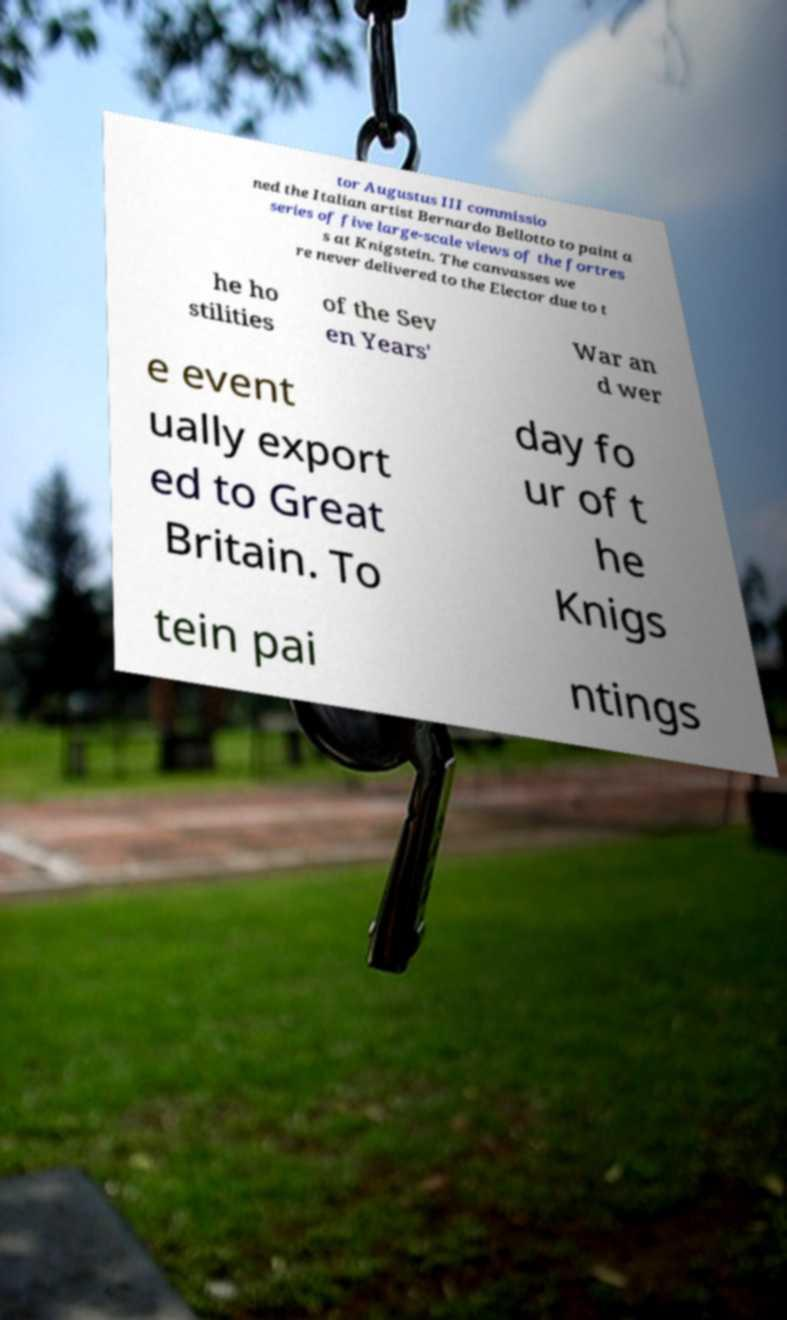Can you read and provide the text displayed in the image?This photo seems to have some interesting text. Can you extract and type it out for me? tor Augustus III commissio ned the Italian artist Bernardo Bellotto to paint a series of five large-scale views of the fortres s at Knigstein. The canvasses we re never delivered to the Elector due to t he ho stilities of the Sev en Years' War an d wer e event ually export ed to Great Britain. To day fo ur of t he Knigs tein pai ntings 